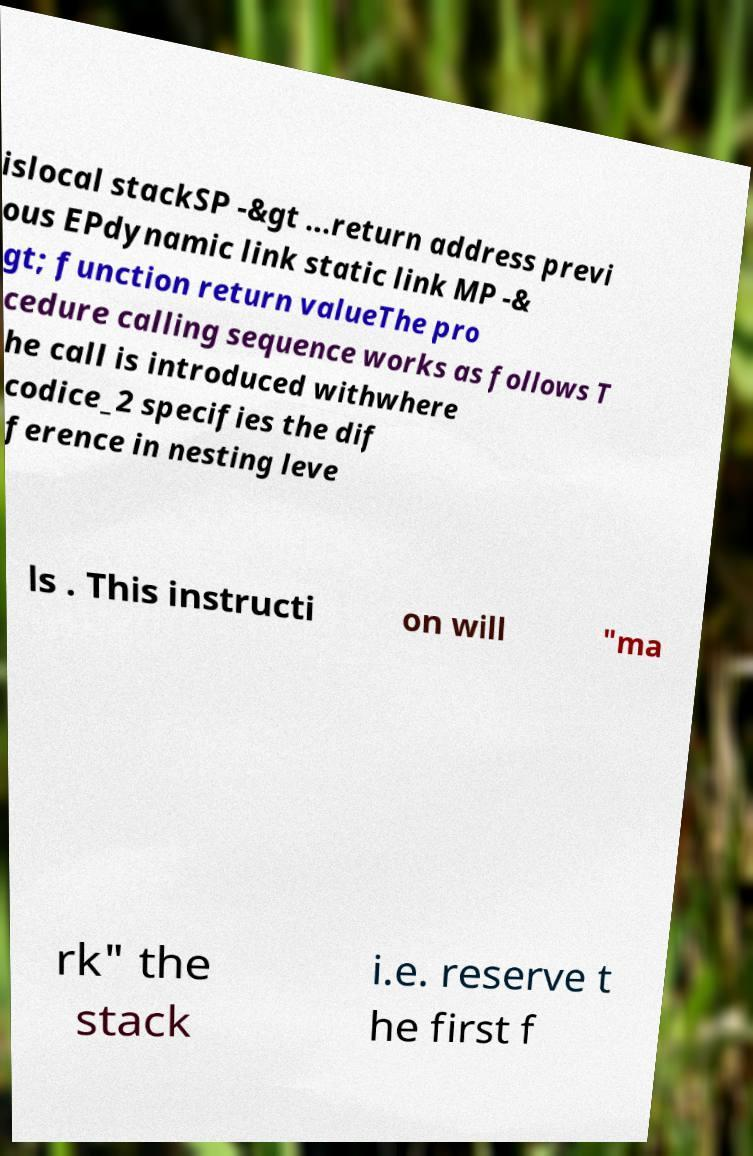Please read and relay the text visible in this image. What does it say? islocal stackSP -&gt ...return address previ ous EPdynamic link static link MP -& gt; function return valueThe pro cedure calling sequence works as follows T he call is introduced withwhere codice_2 specifies the dif ference in nesting leve ls . This instructi on will "ma rk" the stack i.e. reserve t he first f 